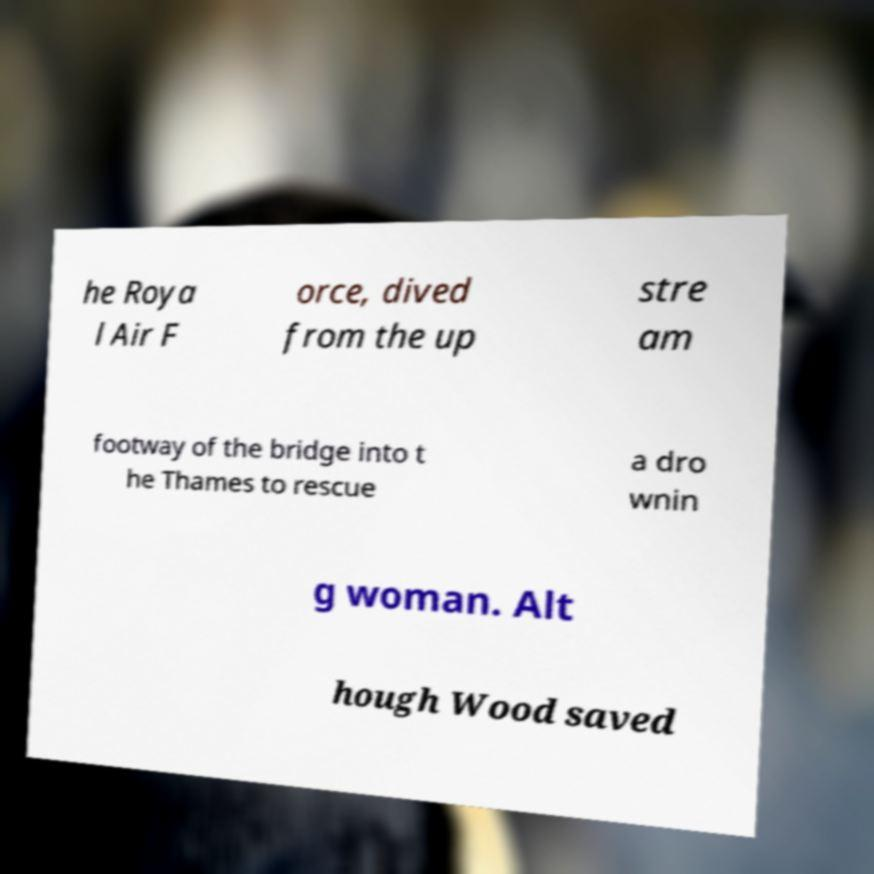Please identify and transcribe the text found in this image. he Roya l Air F orce, dived from the up stre am footway of the bridge into t he Thames to rescue a dro wnin g woman. Alt hough Wood saved 